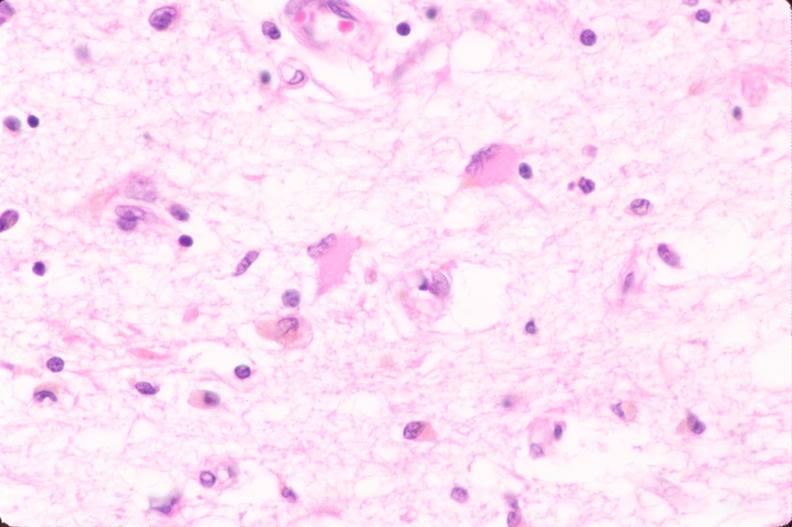what does this image show?
Answer the question using a single word or phrase. Brain 